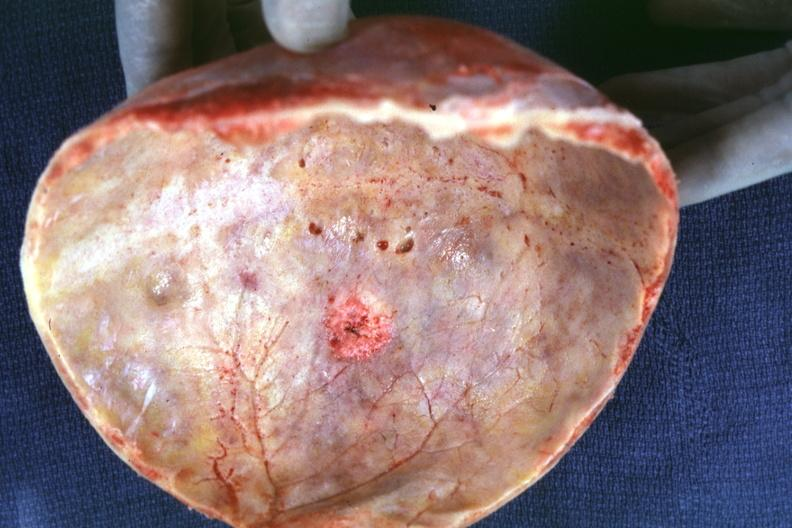what is skull cap with obvious metastatic lesion seen?
Answer the question using a single word or phrase. On inner table prostate primary 